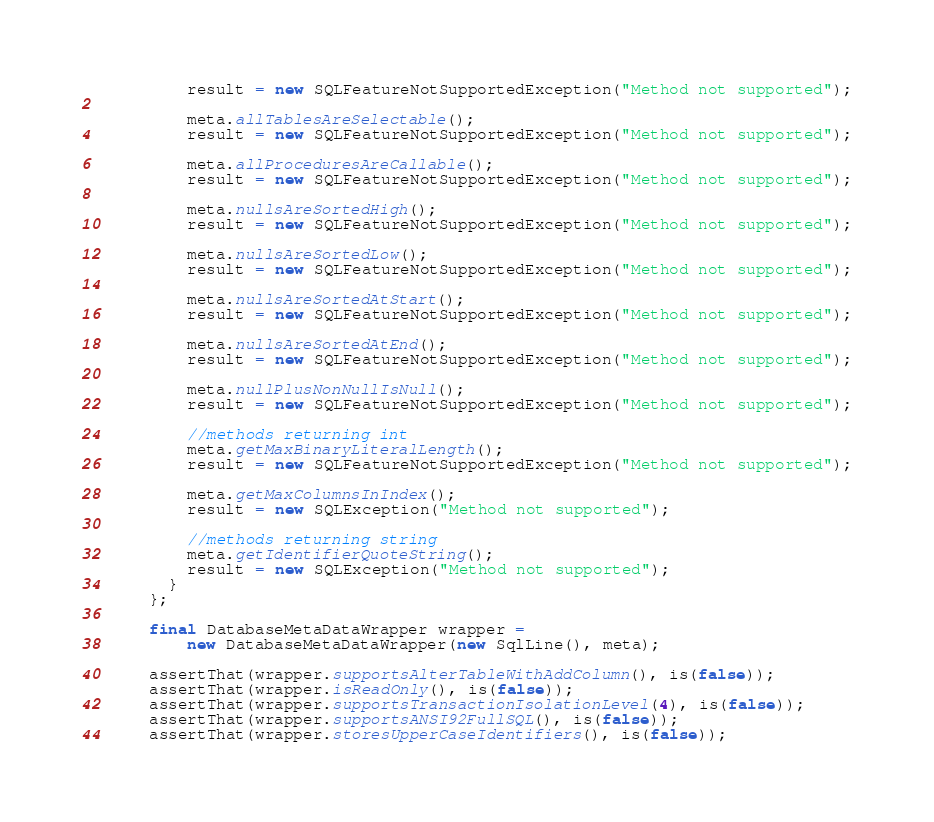Convert code to text. <code><loc_0><loc_0><loc_500><loc_500><_Java_>          result = new SQLFeatureNotSupportedException("Method not supported");

          meta.allTablesAreSelectable();
          result = new SQLFeatureNotSupportedException("Method not supported");

          meta.allProceduresAreCallable();
          result = new SQLFeatureNotSupportedException("Method not supported");

          meta.nullsAreSortedHigh();
          result = new SQLFeatureNotSupportedException("Method not supported");

          meta.nullsAreSortedLow();
          result = new SQLFeatureNotSupportedException("Method not supported");

          meta.nullsAreSortedAtStart();
          result = new SQLFeatureNotSupportedException("Method not supported");

          meta.nullsAreSortedAtEnd();
          result = new SQLFeatureNotSupportedException("Method not supported");

          meta.nullPlusNonNullIsNull();
          result = new SQLFeatureNotSupportedException("Method not supported");

          //methods returning int
          meta.getMaxBinaryLiteralLength();
          result = new SQLFeatureNotSupportedException("Method not supported");

          meta.getMaxColumnsInIndex();
          result = new SQLException("Method not supported");

          //methods returning string
          meta.getIdentifierQuoteString();
          result = new SQLException("Method not supported");
        }
      };

      final DatabaseMetaDataWrapper wrapper =
          new DatabaseMetaDataWrapper(new SqlLine(), meta);

      assertThat(wrapper.supportsAlterTableWithAddColumn(), is(false));
      assertThat(wrapper.isReadOnly(), is(false));
      assertThat(wrapper.supportsTransactionIsolationLevel(4), is(false));
      assertThat(wrapper.supportsANSI92FullSQL(), is(false));
      assertThat(wrapper.storesUpperCaseIdentifiers(), is(false));</code> 